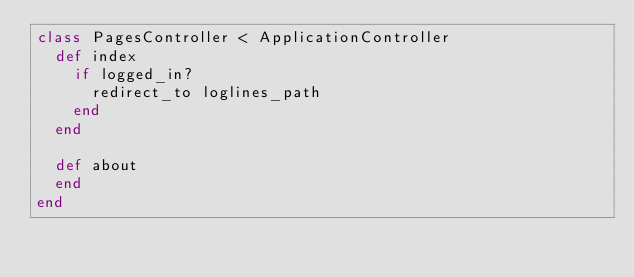<code> <loc_0><loc_0><loc_500><loc_500><_Ruby_>class PagesController < ApplicationController
  def index
  	if logged_in?
  		redirect_to loglines_path
  	end
  end

  def about
  end
end
</code> 